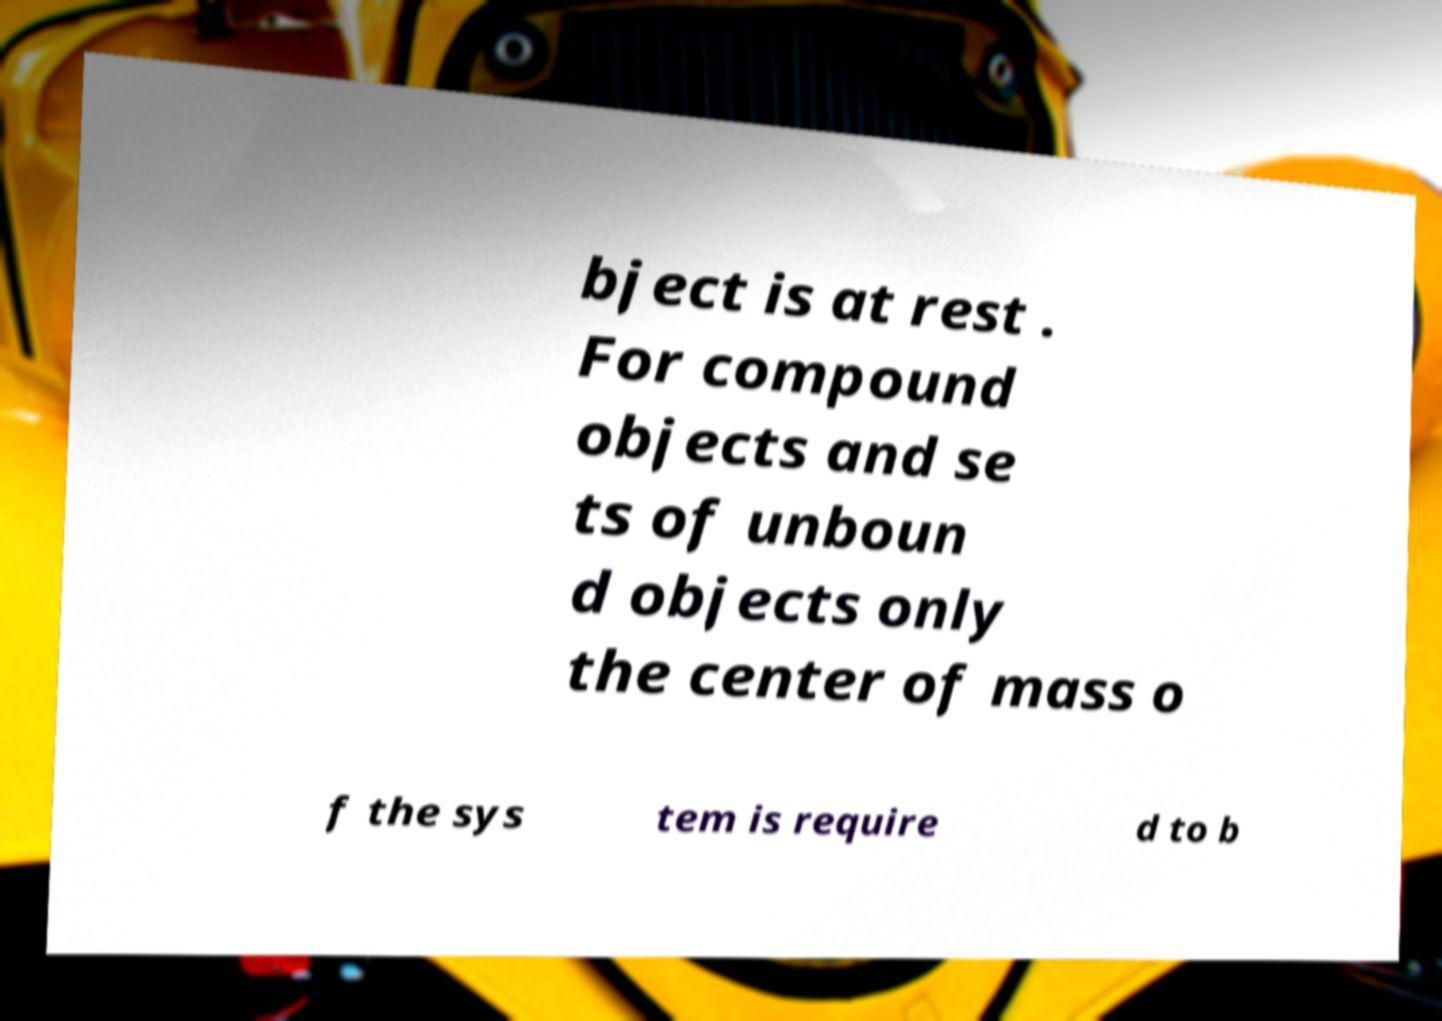Please read and relay the text visible in this image. What does it say? bject is at rest . For compound objects and se ts of unboun d objects only the center of mass o f the sys tem is require d to b 